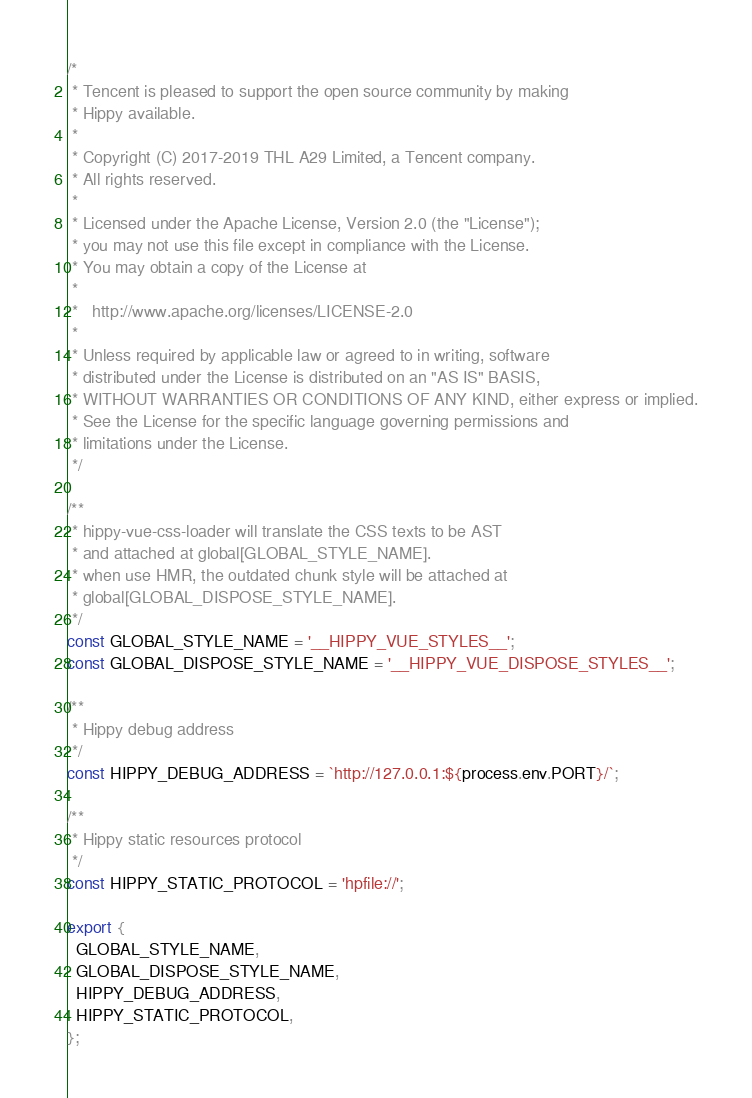Convert code to text. <code><loc_0><loc_0><loc_500><loc_500><_JavaScript_>/*
 * Tencent is pleased to support the open source community by making
 * Hippy available.
 *
 * Copyright (C) 2017-2019 THL A29 Limited, a Tencent company.
 * All rights reserved.
 *
 * Licensed under the Apache License, Version 2.0 (the "License");
 * you may not use this file except in compliance with the License.
 * You may obtain a copy of the License at
 *
 *   http://www.apache.org/licenses/LICENSE-2.0
 *
 * Unless required by applicable law or agreed to in writing, software
 * distributed under the License is distributed on an "AS IS" BASIS,
 * WITHOUT WARRANTIES OR CONDITIONS OF ANY KIND, either express or implied.
 * See the License for the specific language governing permissions and
 * limitations under the License.
 */

/**
 * hippy-vue-css-loader will translate the CSS texts to be AST
 * and attached at global[GLOBAL_STYLE_NAME].
 * when use HMR, the outdated chunk style will be attached at
 * global[GLOBAL_DISPOSE_STYLE_NAME].
 */
const GLOBAL_STYLE_NAME = '__HIPPY_VUE_STYLES__';
const GLOBAL_DISPOSE_STYLE_NAME = '__HIPPY_VUE_DISPOSE_STYLES__';

/**
 * Hippy debug address
 */
const HIPPY_DEBUG_ADDRESS = `http://127.0.0.1:${process.env.PORT}/`;

/**
 * Hippy static resources protocol
 */
const HIPPY_STATIC_PROTOCOL = 'hpfile://';

export {
  GLOBAL_STYLE_NAME,
  GLOBAL_DISPOSE_STYLE_NAME,
  HIPPY_DEBUG_ADDRESS,
  HIPPY_STATIC_PROTOCOL,
};
</code> 